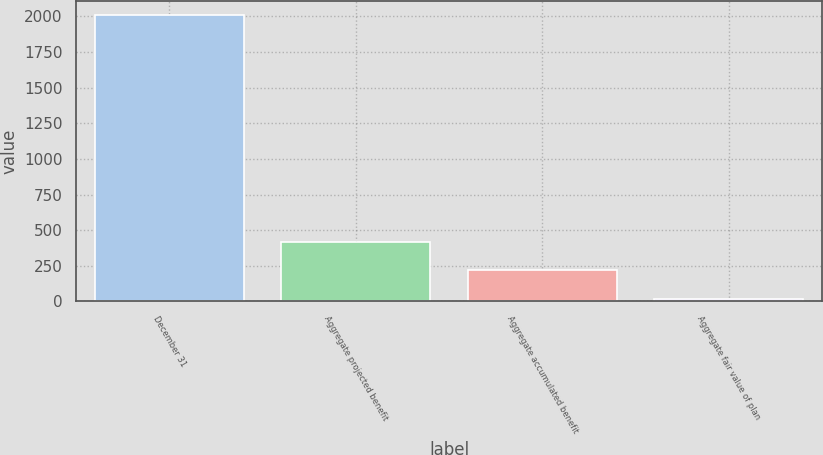<chart> <loc_0><loc_0><loc_500><loc_500><bar_chart><fcel>December 31<fcel>Aggregate projected benefit<fcel>Aggregate accumulated benefit<fcel>Aggregate fair value of plan<nl><fcel>2011<fcel>418.36<fcel>219.28<fcel>20.2<nl></chart> 